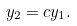Convert formula to latex. <formula><loc_0><loc_0><loc_500><loc_500>y _ { 2 } = c y _ { 1 } .</formula> 